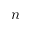Convert formula to latex. <formula><loc_0><loc_0><loc_500><loc_500>n</formula> 